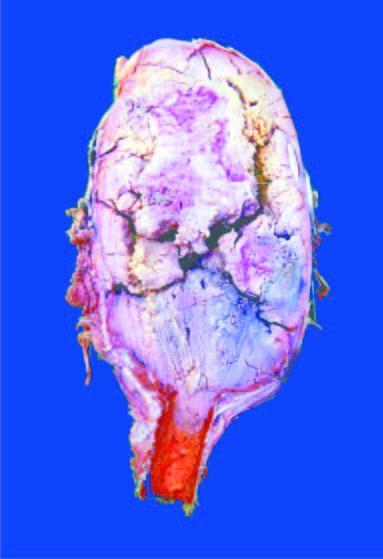does iron on absorption from upper small intestine show circumscribed, dark tan, haemorrhagic and necrotic tumour?
Answer the question using a single word or phrase. No 